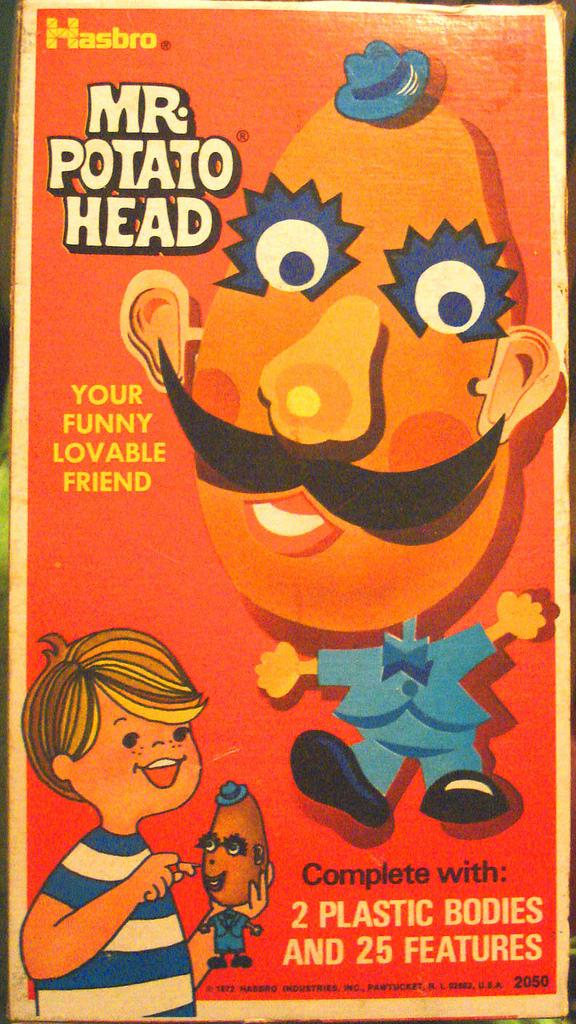<image>
Summarize the visual content of the image. A Mr. Potato Head advertisement with a quote about a funny lovable friend 